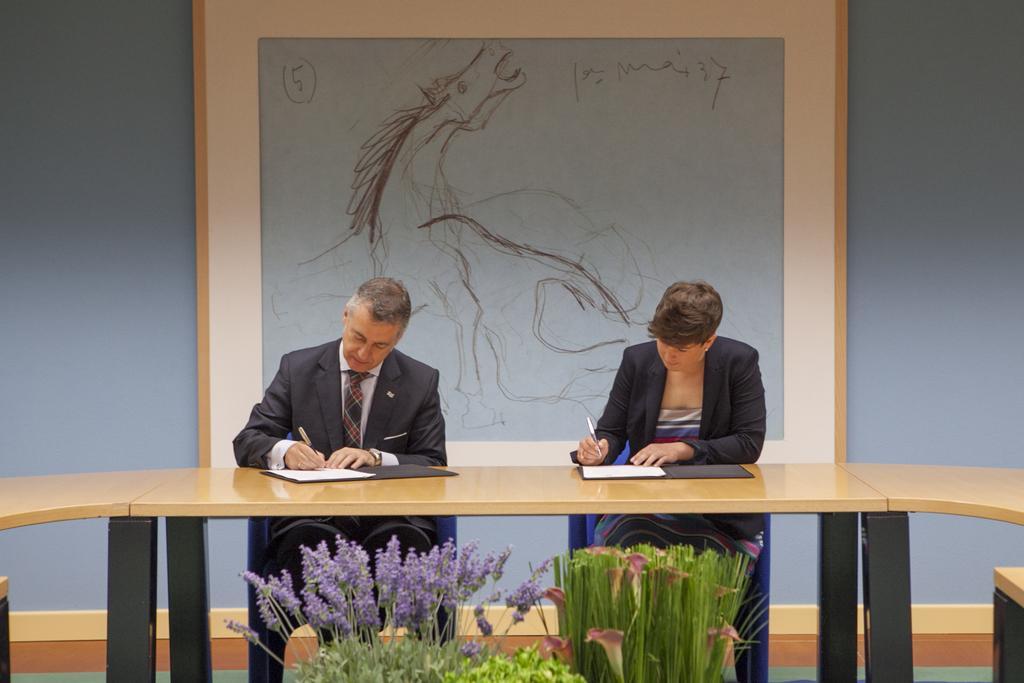Describe this image in one or two sentences. A man and a woman are sitting at a table and writing something on a file with a pen. There is a painting in their background. There are some plants in the front of the table. 